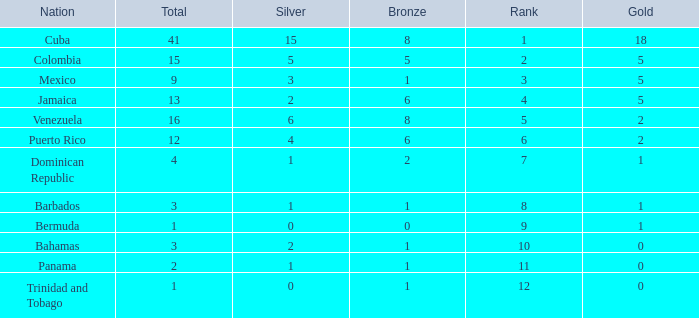Which Bronze is the highest one that has a Rank larger than 1, and a Nation of dominican republic, and a Total larger than 4? None. 